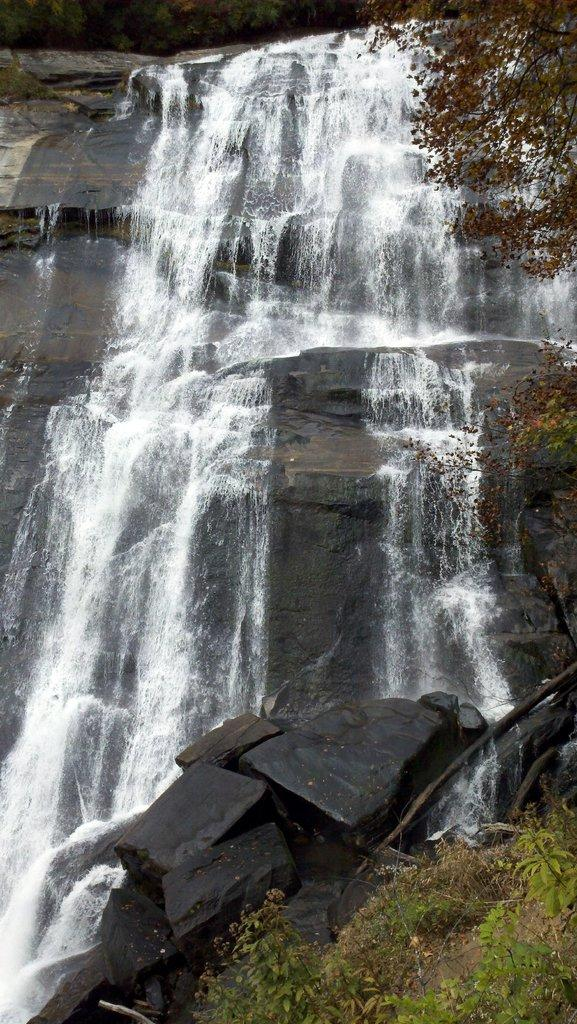What natural feature is the main subject of the image? There is a waterfall in the image. What type of vegetation is present in the image? Leaves are visible on the top, right side, and bottom side of the image. How many cherries are on the basketball in the image? There is no basketball or cherries present in the image. 